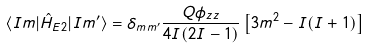Convert formula to latex. <formula><loc_0><loc_0><loc_500><loc_500>\langle I m | \hat { H } _ { E 2 } | I m ^ { \prime } \rangle = \delta _ { m m ^ { \prime } } \frac { Q \phi _ { z z } } { 4 I ( 2 I - 1 ) } \left [ 3 m ^ { 2 } - I ( I + 1 ) \right ]</formula> 